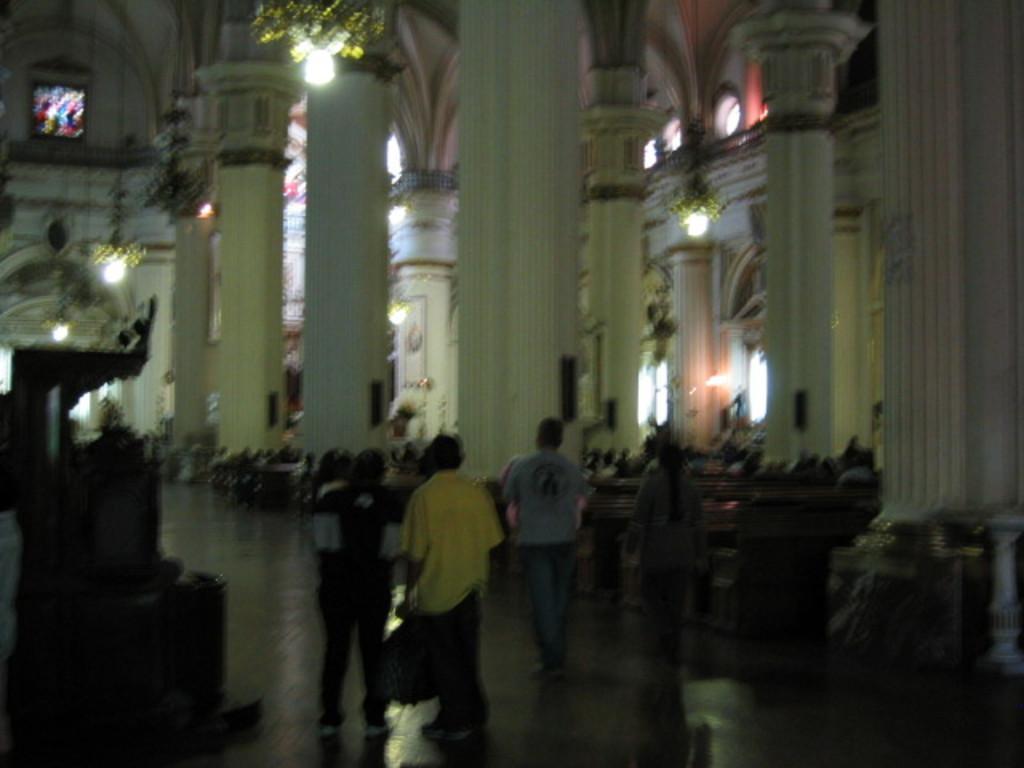How would you summarize this image in a sentence or two? On the bottom there is a man who is wearing yellow t-shirt, jeans and shoe, standing near to this person. On the background we can see many peoples are sitting on the bench. On the top we can see a chandelier. On the background we can see windows, pillars and other objects. On the top left corner there is a painting. 